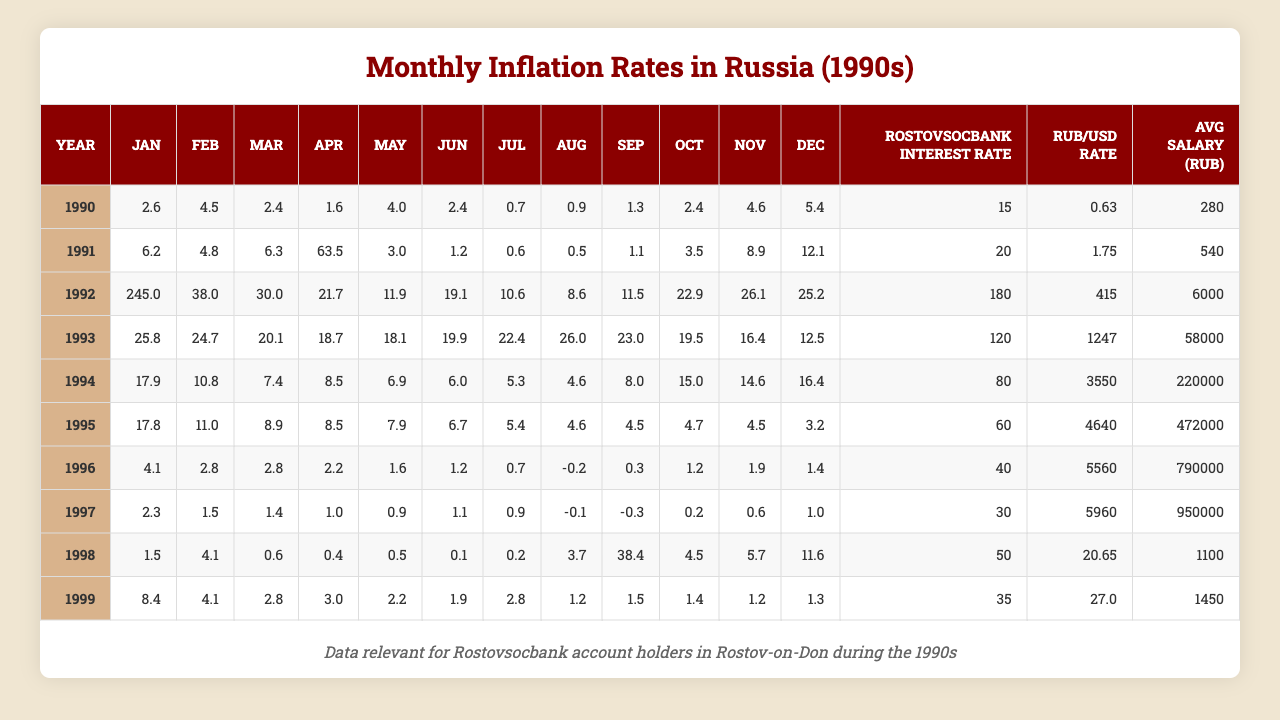What was the highest monthly inflation rate in Russia during the 1990s? The table shows the monthly inflation rates for each year from January to December. The highest inflation rate recorded is 415% in 1992 for the month of March.
Answer: 415% In which month of 1994 was the inflation rate the lowest? In 1994, the monthly inflation rates were the following: January (17.9%), February (10.8%), March (7.4%), April (8.5%), May (6.9%), June (6.0%), July (5.3%), August (4.6%), September (8.0%), October (15.0%), November (14.6%), and December (16.4%). The lowest inflation rate was in August with 4.6%.
Answer: August What was the average inflation rate in 1991? To find the average inflation rate for 1991, sum all monthly rates and then divide by 12. The rates are (6.2 + 4.8 + 6.3 + 63.5 + 3.0 + 1.2 + 0.6 + 0.5 + 1.1 + 3.5 + 8.9 + 12.1) = 108.7. Dividing this by 12 gives an average of approximately 9.06%.
Answer: 9.06% Is the average salary in Rostov-on-Don higher in 1995 or 1996? The average salary in 1995 is 472,000 RUB, while in 1996 it is 790,000 RUB. Since 790,000 is greater than 472,000, the average salary is higher in 1996.
Answer: Yes, it's higher in 1996 What was the trend of inflation from January to December in 1993? Looking at the inflation rates for 1993, they start at 25.8% in January, peak at 30.0% in March, and then drop in subsequent months, ending with 12.5% in December. This indicates a fluctuating trend with a peak in March.
Answer: Fluctuating trend peaking in March How much did the Ruble to USD exchange rate change from 1990 to 1999? The table shows the Ruble to USD exchange rate for 1990 as 0.63 and for 1999 as 27.00. The change can be calculated as 27.00 - 0.63 = 26.37, indicating a significant depreciation of the Ruble against the USD over the decade.
Answer: Changed by 26.37 Which year had the lowest Rostovsocbank interest rate, and what was it? The table shows the Rostovsocbank interest rates: 15 (1990), 20 (1991), 180 (1992), 120 (1993), 80 (1994), 60 (1995), 40 (1996), 30 (1997), 50 (1998), and 35 (1999). The lowest interest rate was 30% in 1997.
Answer: 30% in 1997 What was the inflation rate for October in the year where March had the highest inflation? In 1992, March had the highest inflation rate of 415%, and for October 1992, the rate was 22.9%. This indicates that in the same year, October experienced a significantly lower inflation rate.
Answer: 22.9% What is the difference in inflation rates between the highest and lowest month in 1992? In 1992, the highest inflation rate was 415% in March, while the lowest was 8.6% in August. The difference can be calculated as 415 - 8.6 = 406.4.
Answer: 406.4% difference In which year did the inflation rates on average begin to decline significantly? Reviewing the data indicates 1994 marked a peak and appears to begin a general decline with inflation rates lower in 1995, and further down in subsequent years, especially in 1997 and 1998. Thus, the significant decline began after 1993.
Answer: After 1993 